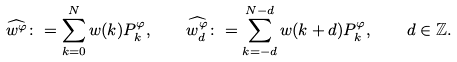<formula> <loc_0><loc_0><loc_500><loc_500>\widehat { w ^ { \varphi } } \colon = \sum _ { k = 0 } ^ { N } w ( k ) P _ { k } ^ { \varphi } , \quad \widehat { w _ { d } ^ { \varphi } } \colon = \sum _ { k = - d } ^ { N - d } w ( k + d ) P _ { k } ^ { \varphi } , \quad d \in \mathbb { Z } .</formula> 